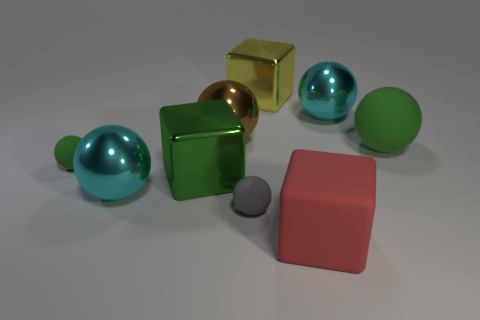Are there any other things that are the same color as the large rubber cube?
Ensure brevity in your answer.  No. Are there any other things that are the same size as the brown metallic ball?
Give a very brief answer. Yes. What number of objects are cyan metallic things or tiny gray objects?
Your answer should be very brief. 3. Is there a cyan matte sphere of the same size as the red rubber block?
Give a very brief answer. No. What is the shape of the large brown object?
Provide a succinct answer. Sphere. Are there more big green objects that are in front of the red cube than green spheres behind the brown metal sphere?
Ensure brevity in your answer.  No. Do the small matte sphere that is right of the big brown thing and the small sphere behind the small gray rubber sphere have the same color?
Your answer should be very brief. No. What is the shape of the red object that is the same size as the green shiny thing?
Give a very brief answer. Cube. Are there any big yellow things that have the same shape as the red rubber object?
Your answer should be very brief. Yes. Does the cyan object that is on the right side of the large yellow shiny object have the same material as the big cube that is on the right side of the large yellow object?
Provide a succinct answer. No. 